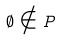Convert formula to latex. <formula><loc_0><loc_0><loc_500><loc_500>\emptyset \notin P</formula> 